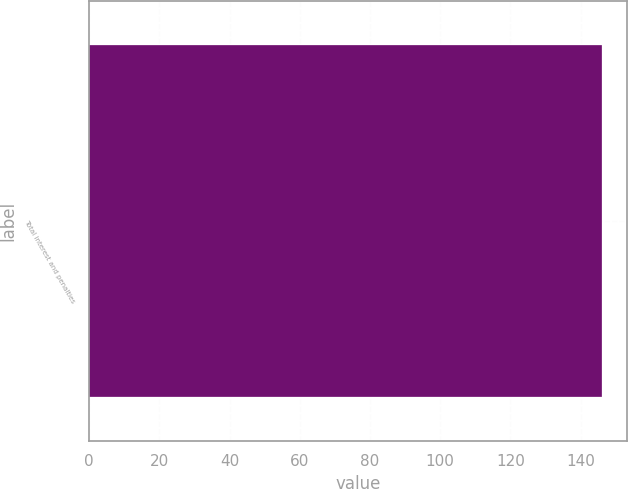<chart> <loc_0><loc_0><loc_500><loc_500><bar_chart><fcel>Total interest and penalties<nl><fcel>146<nl></chart> 